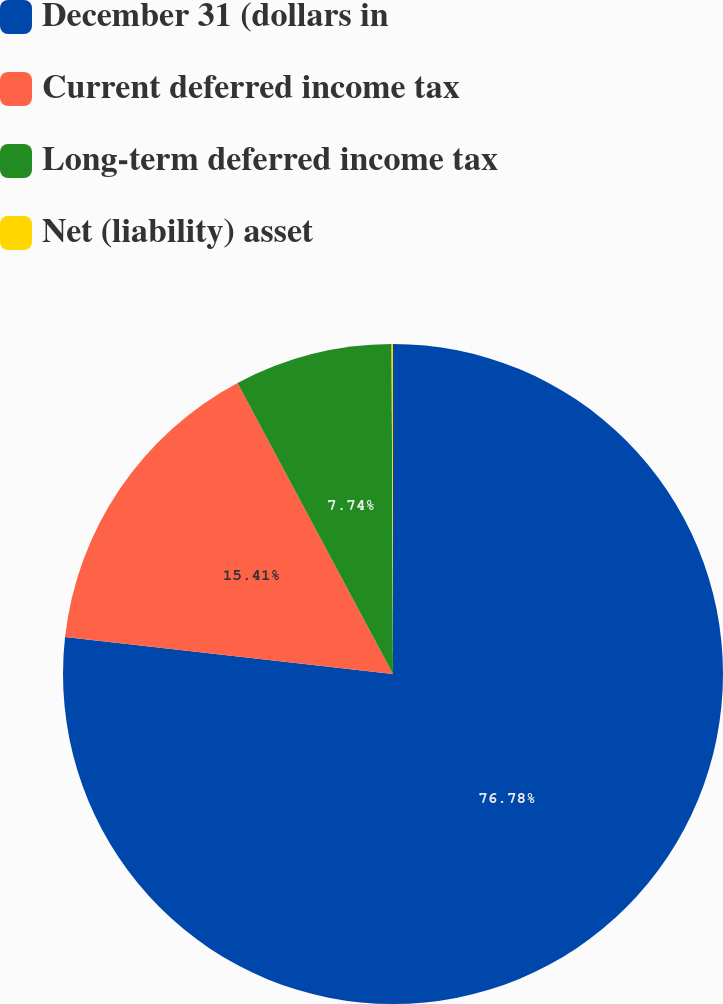<chart> <loc_0><loc_0><loc_500><loc_500><pie_chart><fcel>December 31 (dollars in<fcel>Current deferred income tax<fcel>Long-term deferred income tax<fcel>Net (liability) asset<nl><fcel>76.79%<fcel>15.41%<fcel>7.74%<fcel>0.07%<nl></chart> 